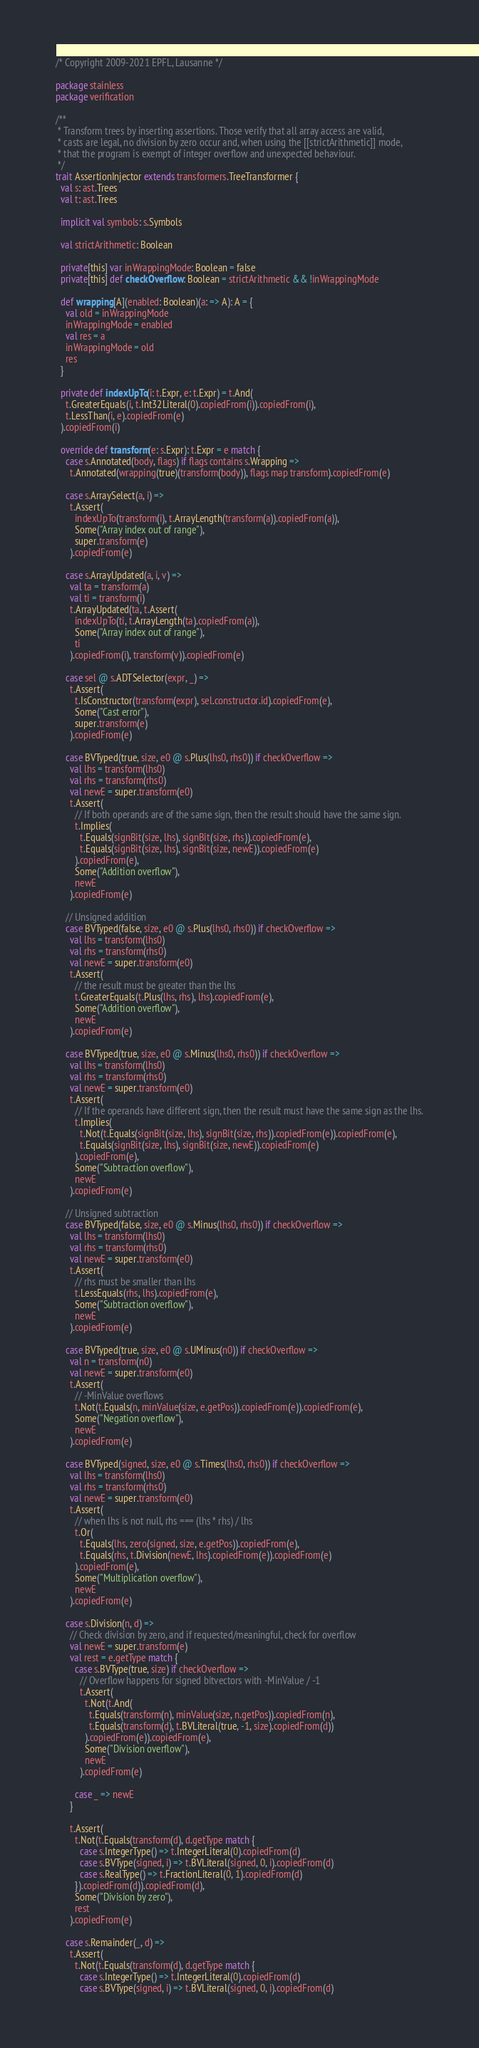Convert code to text. <code><loc_0><loc_0><loc_500><loc_500><_Scala_>/* Copyright 2009-2021 EPFL, Lausanne */

package stainless
package verification

/**
 * Transform trees by inserting assertions. Those verify that all array access are valid,
 * casts are legal, no division by zero occur and, when using the [[strictArithmetic]] mode,
 * that the program is exempt of integer overflow and unexpected behaviour.
 */
trait AssertionInjector extends transformers.TreeTransformer {
  val s: ast.Trees
  val t: ast.Trees

  implicit val symbols: s.Symbols

  val strictArithmetic: Boolean

  private[this] var inWrappingMode: Boolean = false
  private[this] def checkOverflow: Boolean = strictArithmetic && !inWrappingMode

  def wrapping[A](enabled: Boolean)(a: => A): A = {
    val old = inWrappingMode
    inWrappingMode = enabled
    val res = a
    inWrappingMode = old
    res
  }

  private def indexUpTo(i: t.Expr, e: t.Expr) = t.And(
    t.GreaterEquals(i, t.Int32Literal(0).copiedFrom(i)).copiedFrom(i),
    t.LessThan(i, e).copiedFrom(e)
  ).copiedFrom(i)

  override def transform(e: s.Expr): t.Expr = e match {
    case s.Annotated(body, flags) if flags contains s.Wrapping =>
      t.Annotated(wrapping(true)(transform(body)), flags map transform).copiedFrom(e)

    case s.ArraySelect(a, i) =>
      t.Assert(
        indexUpTo(transform(i), t.ArrayLength(transform(a)).copiedFrom(a)),
        Some("Array index out of range"),
        super.transform(e)
      ).copiedFrom(e)

    case s.ArrayUpdated(a, i, v) =>
      val ta = transform(a)
      val ti = transform(i)
      t.ArrayUpdated(ta, t.Assert(
        indexUpTo(ti, t.ArrayLength(ta).copiedFrom(a)),
        Some("Array index out of range"),
        ti
      ).copiedFrom(i), transform(v)).copiedFrom(e)

    case sel @ s.ADTSelector(expr, _) =>
      t.Assert(
        t.IsConstructor(transform(expr), sel.constructor.id).copiedFrom(e),
        Some("Cast error"),
        super.transform(e)
      ).copiedFrom(e)

    case BVTyped(true, size, e0 @ s.Plus(lhs0, rhs0)) if checkOverflow =>
      val lhs = transform(lhs0)
      val rhs = transform(rhs0)
      val newE = super.transform(e0)
      t.Assert(
        // If both operands are of the same sign, then the result should have the same sign.
        t.Implies(
          t.Equals(signBit(size, lhs), signBit(size, rhs)).copiedFrom(e),
          t.Equals(signBit(size, lhs), signBit(size, newE)).copiedFrom(e)
        ).copiedFrom(e),
        Some("Addition overflow"),
        newE
      ).copiedFrom(e)

    // Unsigned addition
    case BVTyped(false, size, e0 @ s.Plus(lhs0, rhs0)) if checkOverflow =>
      val lhs = transform(lhs0)
      val rhs = transform(rhs0)
      val newE = super.transform(e0)
      t.Assert(
        // the result must be greater than the lhs
        t.GreaterEquals(t.Plus(lhs, rhs), lhs).copiedFrom(e),
        Some("Addition overflow"),
        newE
      ).copiedFrom(e)

    case BVTyped(true, size, e0 @ s.Minus(lhs0, rhs0)) if checkOverflow =>
      val lhs = transform(lhs0)
      val rhs = transform(rhs0)
      val newE = super.transform(e0)
      t.Assert(
        // If the operands have different sign, then the result must have the same sign as the lhs.
        t.Implies(
          t.Not(t.Equals(signBit(size, lhs), signBit(size, rhs)).copiedFrom(e)).copiedFrom(e),
          t.Equals(signBit(size, lhs), signBit(size, newE)).copiedFrom(e)
        ).copiedFrom(e),
        Some("Subtraction overflow"),
        newE
      ).copiedFrom(e)

    // Unsigned subtraction
    case BVTyped(false, size, e0 @ s.Minus(lhs0, rhs0)) if checkOverflow =>
      val lhs = transform(lhs0)
      val rhs = transform(rhs0)
      val newE = super.transform(e0)
      t.Assert(
        // rhs must be smaller than lhs
        t.LessEquals(rhs, lhs).copiedFrom(e),
        Some("Subtraction overflow"),
        newE
      ).copiedFrom(e)

    case BVTyped(true, size, e0 @ s.UMinus(n0)) if checkOverflow =>
      val n = transform(n0)
      val newE = super.transform(e0)
      t.Assert(
        // -MinValue overflows
        t.Not(t.Equals(n, minValue(size, e.getPos)).copiedFrom(e)).copiedFrom(e),
        Some("Negation overflow"),
        newE
      ).copiedFrom(e)

    case BVTyped(signed, size, e0 @ s.Times(lhs0, rhs0)) if checkOverflow =>
      val lhs = transform(lhs0)
      val rhs = transform(rhs0)
      val newE = super.transform(e0)
      t.Assert(
        // when lhs is not null, rhs === (lhs * rhs) / lhs
        t.Or(
          t.Equals(lhs, zero(signed, size, e.getPos)).copiedFrom(e),
          t.Equals(rhs, t.Division(newE, lhs).copiedFrom(e)).copiedFrom(e)
        ).copiedFrom(e),
        Some("Multiplication overflow"),
        newE
      ).copiedFrom(e)

    case s.Division(n, d) =>
      // Check division by zero, and if requested/meaningful, check for overflow
      val newE = super.transform(e)
      val rest = e.getType match {
        case s.BVType(true, size) if checkOverflow =>
          // Overflow happens for signed bitvectors with -MinValue / -1
          t.Assert(
            t.Not(t.And(
              t.Equals(transform(n), minValue(size, n.getPos)).copiedFrom(n),
              t.Equals(transform(d), t.BVLiteral(true, -1, size).copiedFrom(d))
            ).copiedFrom(e)).copiedFrom(e),
            Some("Division overflow"),
            newE
          ).copiedFrom(e)

        case _ => newE
      }

      t.Assert(
        t.Not(t.Equals(transform(d), d.getType match {
          case s.IntegerType() => t.IntegerLiteral(0).copiedFrom(d)
          case s.BVType(signed, i) => t.BVLiteral(signed, 0, i).copiedFrom(d)
          case s.RealType() => t.FractionLiteral(0, 1).copiedFrom(d)
        }).copiedFrom(d)).copiedFrom(d),
        Some("Division by zero"),
        rest
      ).copiedFrom(e)

    case s.Remainder(_, d) =>
      t.Assert(
        t.Not(t.Equals(transform(d), d.getType match {
          case s.IntegerType() => t.IntegerLiteral(0).copiedFrom(d)
          case s.BVType(signed, i) => t.BVLiteral(signed, 0, i).copiedFrom(d)</code> 